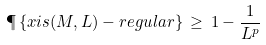Convert formula to latex. <formula><loc_0><loc_0><loc_500><loc_500>\P \left \{ x i s ( M , L ) - r e g u l a r \right \} \, \geq \, 1 - \frac { 1 } { L ^ { p } }</formula> 